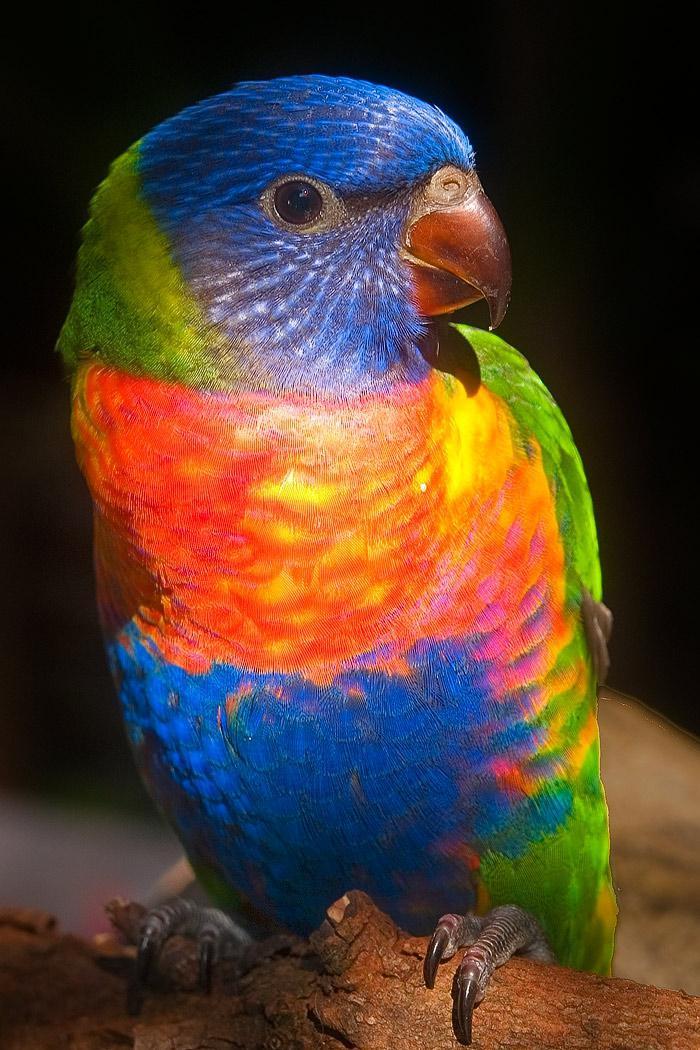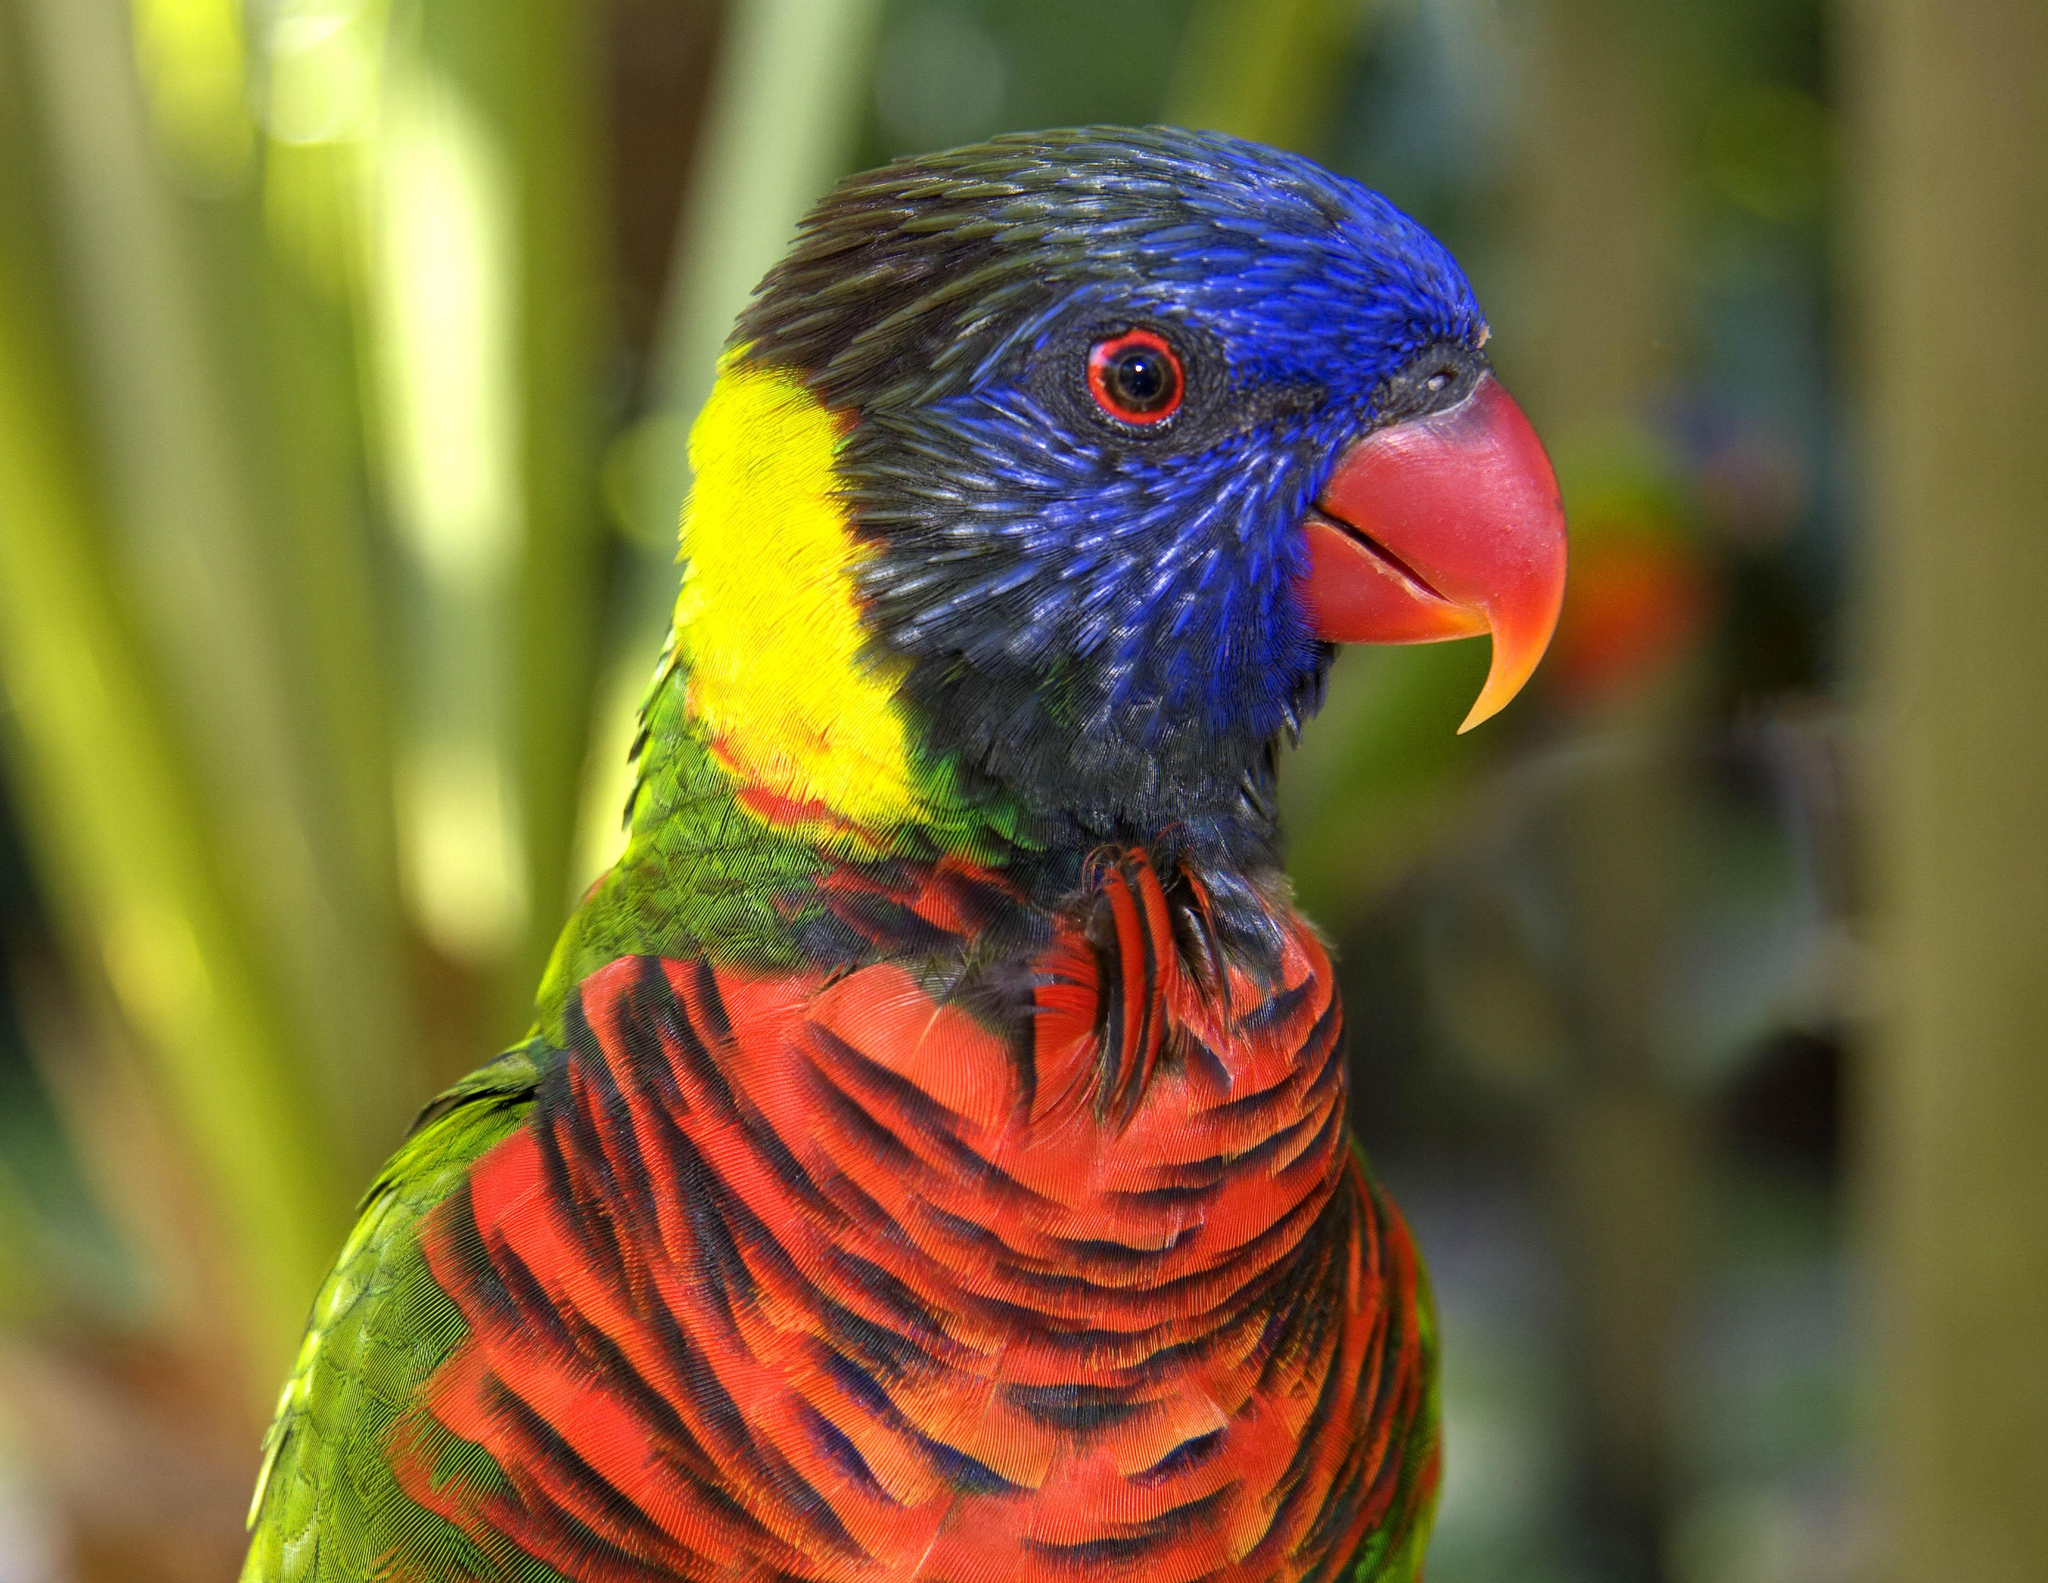The first image is the image on the left, the second image is the image on the right. Considering the images on both sides, is "There are at most 4 birds pictured." valid? Answer yes or no. Yes. 